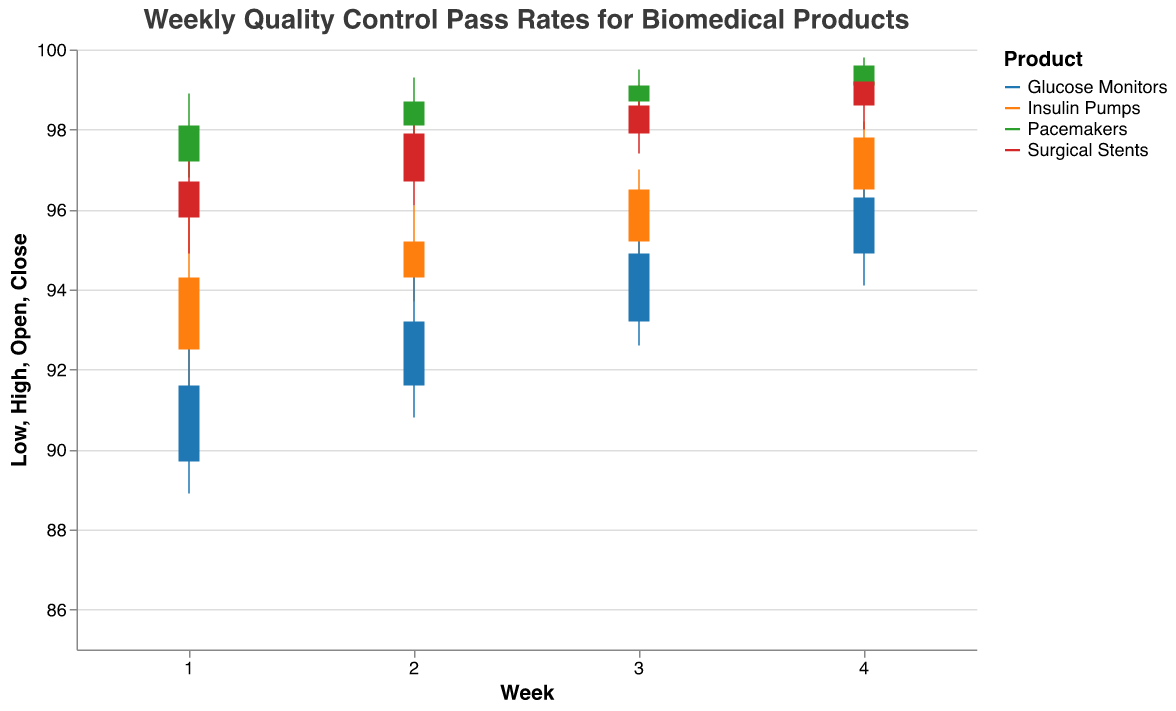What's the title of the chart? The chart's title can be found at the top and indicates the content or subject of the chart.
Answer: Weekly Quality Control Pass Rates for Biomedical Products How does the quality control pass rate for Insulin Pumps change from Week 1 to Week 4? The chart shows the opening, high, low, and closing rates for each week. For Insulin Pumps, Week 1's close is 94.3%, and it increases each week, closing at 95.2%, 96.5%, and 97.8% in the subsequent weeks.
Answer: It increases each week Which product has the highest closing pass rate in Week 4? By examining the closing rates for Week 4 for all products, Pacemakers have the highest closing rate of 99.6%.
Answer: Pacemakers What is the range of quality control pass rates for Glucose Monitors in Week 2? The range is calculated by subtracting the lowest value from the highest value. In Week 2 for Glucose Monitors, the high is 94.5% and the low is 90.8%, so the range is 94.5 - 90.8.
Answer: 3.7% Which product line shows the most consistent (least variable) quality control pass rates over the four weeks? The consistency can be seen by determining the product line with the smallest differences between high and low values over four weeks. Pacemakers' values range narrowly around the high 90% mark.
Answer: Pacemakers Did any product experience a week where the closing rate was lower than the opening rate? This can be identified by looking for cases where the Close value is lower than the Open value. None of the product lines show a week where the closing rate is lower than the opening rate.
Answer: No In Week 3, which product had the highest maximum pass rate, and what was that rate? The maximum pass rate is represented by the High value. In Week 3, Pacemakers had the highest maximum pass rate with a value of 99.5%.
Answer: Pacemakers, 99.5% For Surgical Stents, calculate the average of the closing rates over the four weeks. The average closing rate for Surgical Stents can be calculated by summing the closing rates for Weeks 1 to 4 and then dividing by 4: (96.7 + 97.9 + 98.6 + 99.2) / 4.
Answer: 98.1% Compare the Week 2 closing rates for Insulin Pumps and Glucose Monitors. Which is higher? In Week 2, the closing rate for Insulin Pumps is 95.2%, and for Glucose Monitors, it is 93.2%. Therefore, Insulin Pumps have a higher closing rate.
Answer: Insulin Pumps What is the difference between the highest closing rate and the lowest closing rate observed across all product lines and weeks? The highest observed closing rate is 99.6% (Pacemakers, Week 4) and the lowest is 91.6% (Glucose Monitors, Week 1). The difference is 99.6 - 91.6.
Answer: 8% 